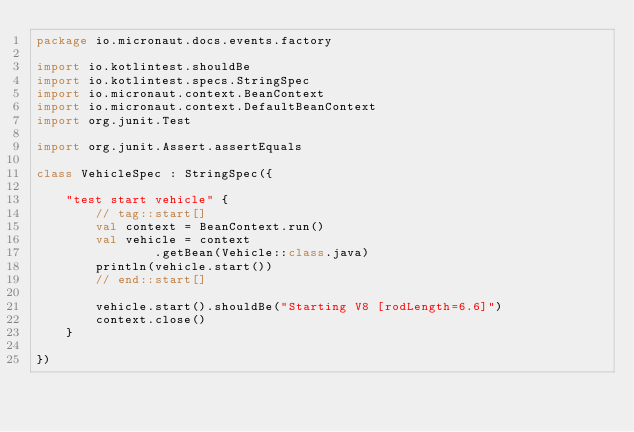<code> <loc_0><loc_0><loc_500><loc_500><_Kotlin_>package io.micronaut.docs.events.factory

import io.kotlintest.shouldBe
import io.kotlintest.specs.StringSpec
import io.micronaut.context.BeanContext
import io.micronaut.context.DefaultBeanContext
import org.junit.Test

import org.junit.Assert.assertEquals

class VehicleSpec : StringSpec({

    "test start vehicle" {
        // tag::start[]
        val context = BeanContext.run()
        val vehicle = context
                .getBean(Vehicle::class.java)
        println(vehicle.start())
        // end::start[]

        vehicle.start().shouldBe("Starting V8 [rodLength=6.6]")
        context.close()
    }

})
</code> 